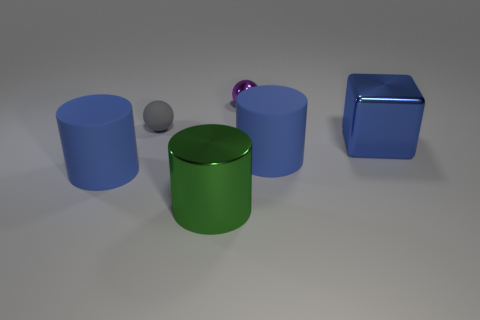Is there a rubber ball of the same color as the big metallic cube?
Give a very brief answer. No. There is a matte object that is the same size as the purple metal object; what is its shape?
Give a very brief answer. Sphere. What number of large blue shiny objects are in front of the big blue cylinder that is to the left of the small gray matte object?
Offer a very short reply. 0. Does the metallic sphere have the same color as the big block?
Ensure brevity in your answer.  No. What number of other things are there of the same material as the large green thing
Your answer should be very brief. 2. There is a large blue matte object on the left side of the shiny thing in front of the cube; what is its shape?
Give a very brief answer. Cylinder. What is the size of the shiny thing left of the metallic sphere?
Make the answer very short. Large. Do the big green object and the tiny gray ball have the same material?
Your answer should be very brief. No. There is a blue object that is the same material as the large green object; what is its shape?
Offer a very short reply. Cube. Are there any other things that are the same color as the block?
Give a very brief answer. Yes. 